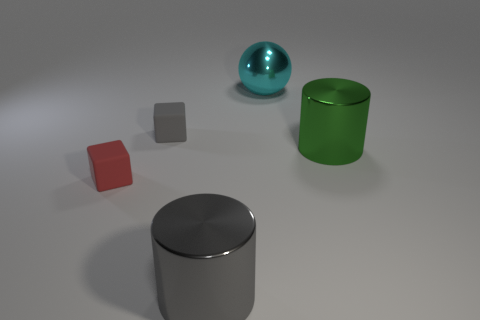Add 3 gray rubber things. How many objects exist? 8 Subtract all gray cubes. How many cubes are left? 1 Subtract all blocks. How many objects are left? 3 Subtract 1 cubes. How many cubes are left? 1 Subtract all red blocks. Subtract all red matte cubes. How many objects are left? 3 Add 1 shiny balls. How many shiny balls are left? 2 Add 3 large cyan shiny spheres. How many large cyan shiny spheres exist? 4 Subtract 0 red spheres. How many objects are left? 5 Subtract all purple spheres. Subtract all gray cylinders. How many spheres are left? 1 